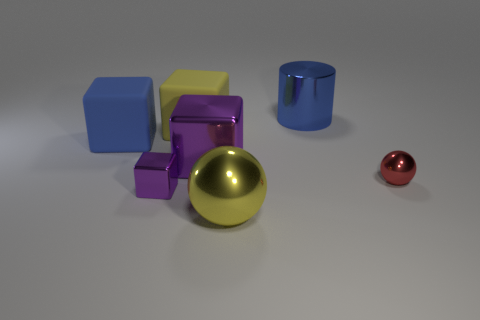There is a object that is both on the right side of the big yellow metallic ball and behind the big blue rubber cube; what color is it?
Provide a short and direct response. Blue. Is the red object the same shape as the large yellow metal thing?
Make the answer very short. Yes. There is a matte object that is the same color as the cylinder; what size is it?
Offer a terse response. Large. The blue thing in front of the matte cube that is behind the blue matte object is what shape?
Provide a succinct answer. Cube. Do the blue rubber thing and the small metal object that is to the right of the blue metal cylinder have the same shape?
Ensure brevity in your answer.  No. What color is the matte thing that is the same size as the yellow cube?
Provide a succinct answer. Blue. Are there fewer big purple blocks that are to the left of the yellow rubber object than yellow cubes right of the small red metallic thing?
Your response must be concise. No. The small thing to the left of the large yellow thing that is in front of the large rubber cube that is left of the small shiny cube is what shape?
Offer a very short reply. Cube. There is a metallic ball that is in front of the small red shiny ball; does it have the same color as the rubber object that is right of the large blue cube?
Keep it short and to the point. Yes. There is a rubber object that is the same color as the large shiny cylinder; what is its shape?
Your answer should be very brief. Cube. 